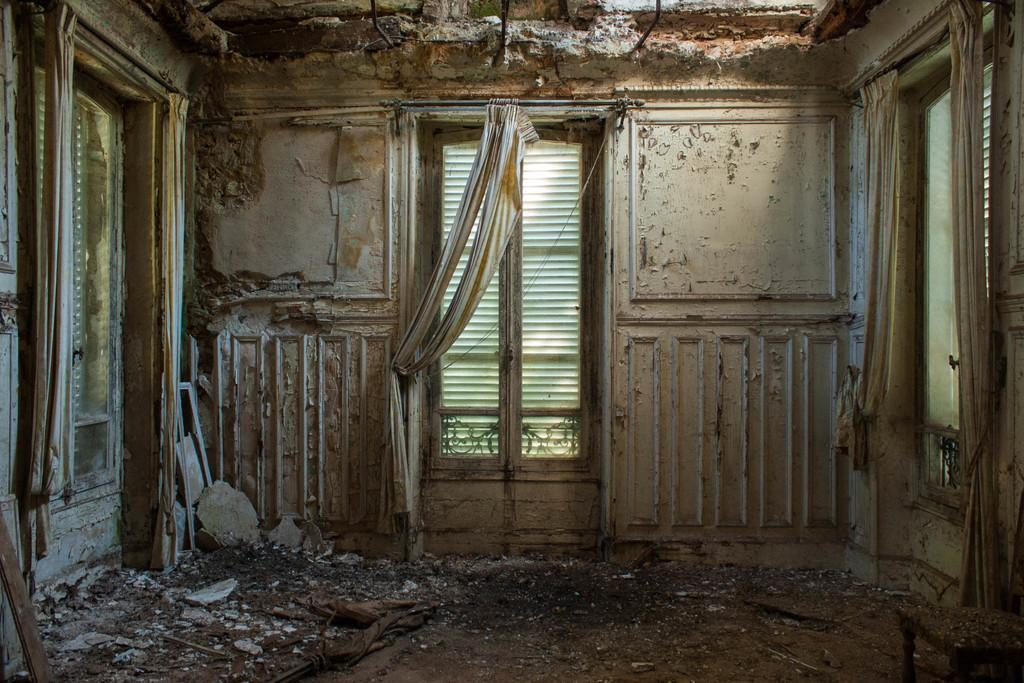What type of building is in the picture? There is an old house in the picture. What are some features of the house? The house has doors and curtains. Are there any other objects related to the curtains? Yes, there are rods in the house. How does the floor look in the picture? The floor at the bottom portion of the picture appears messy. What belief is depicted on the page in the picture? There is no page present in the image, so it is not possible to determine any beliefs depicted. 